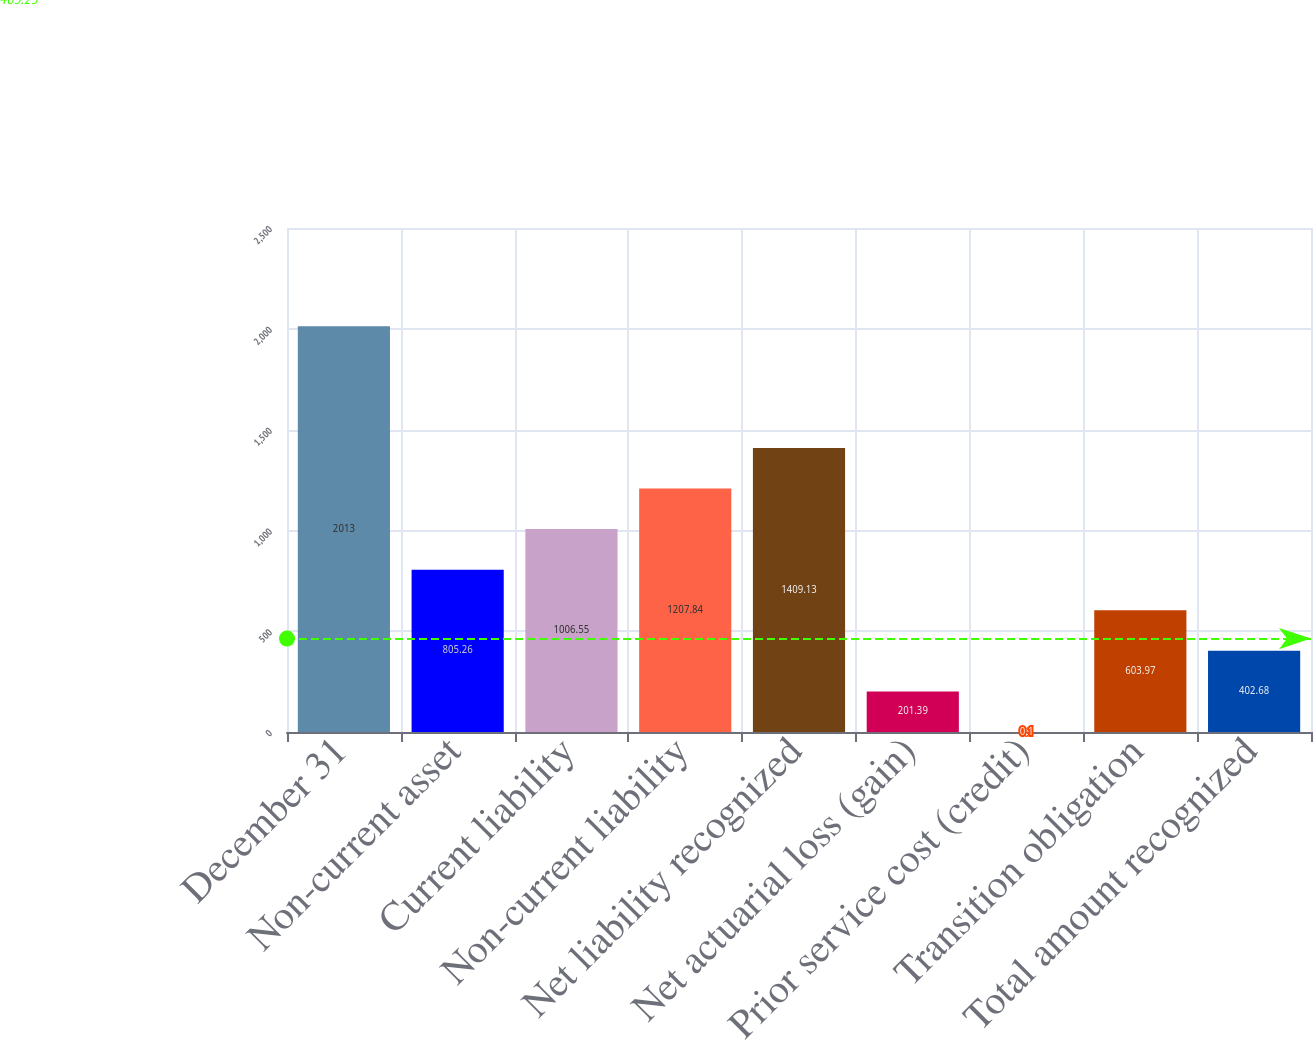Convert chart. <chart><loc_0><loc_0><loc_500><loc_500><bar_chart><fcel>December 31<fcel>Non-current asset<fcel>Current liability<fcel>Non-current liability<fcel>Net liability recognized<fcel>Net actuarial loss (gain)<fcel>Prior service cost (credit)<fcel>Transition obligation<fcel>Total amount recognized<nl><fcel>2013<fcel>805.26<fcel>1006.55<fcel>1207.84<fcel>1409.13<fcel>201.39<fcel>0.1<fcel>603.97<fcel>402.68<nl></chart> 